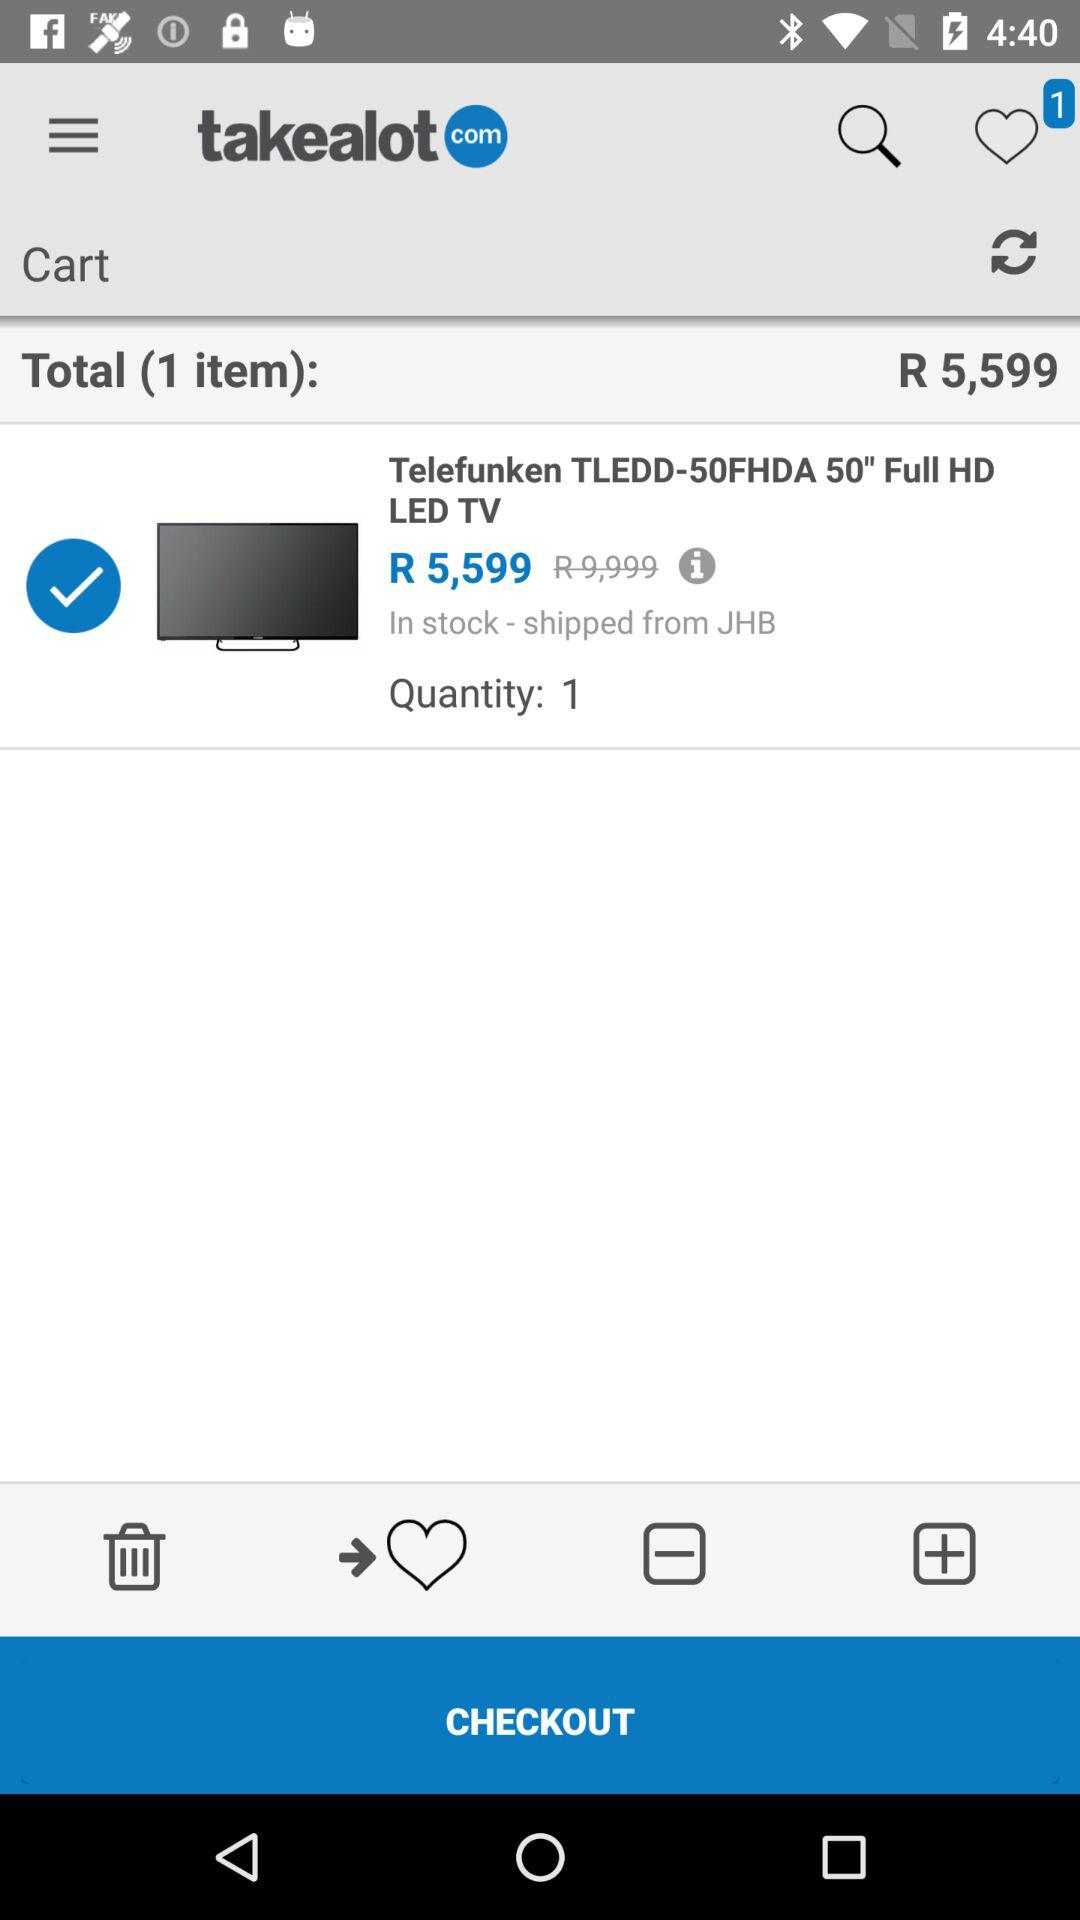What is the name of the application? The name of the application is "takealot com". 